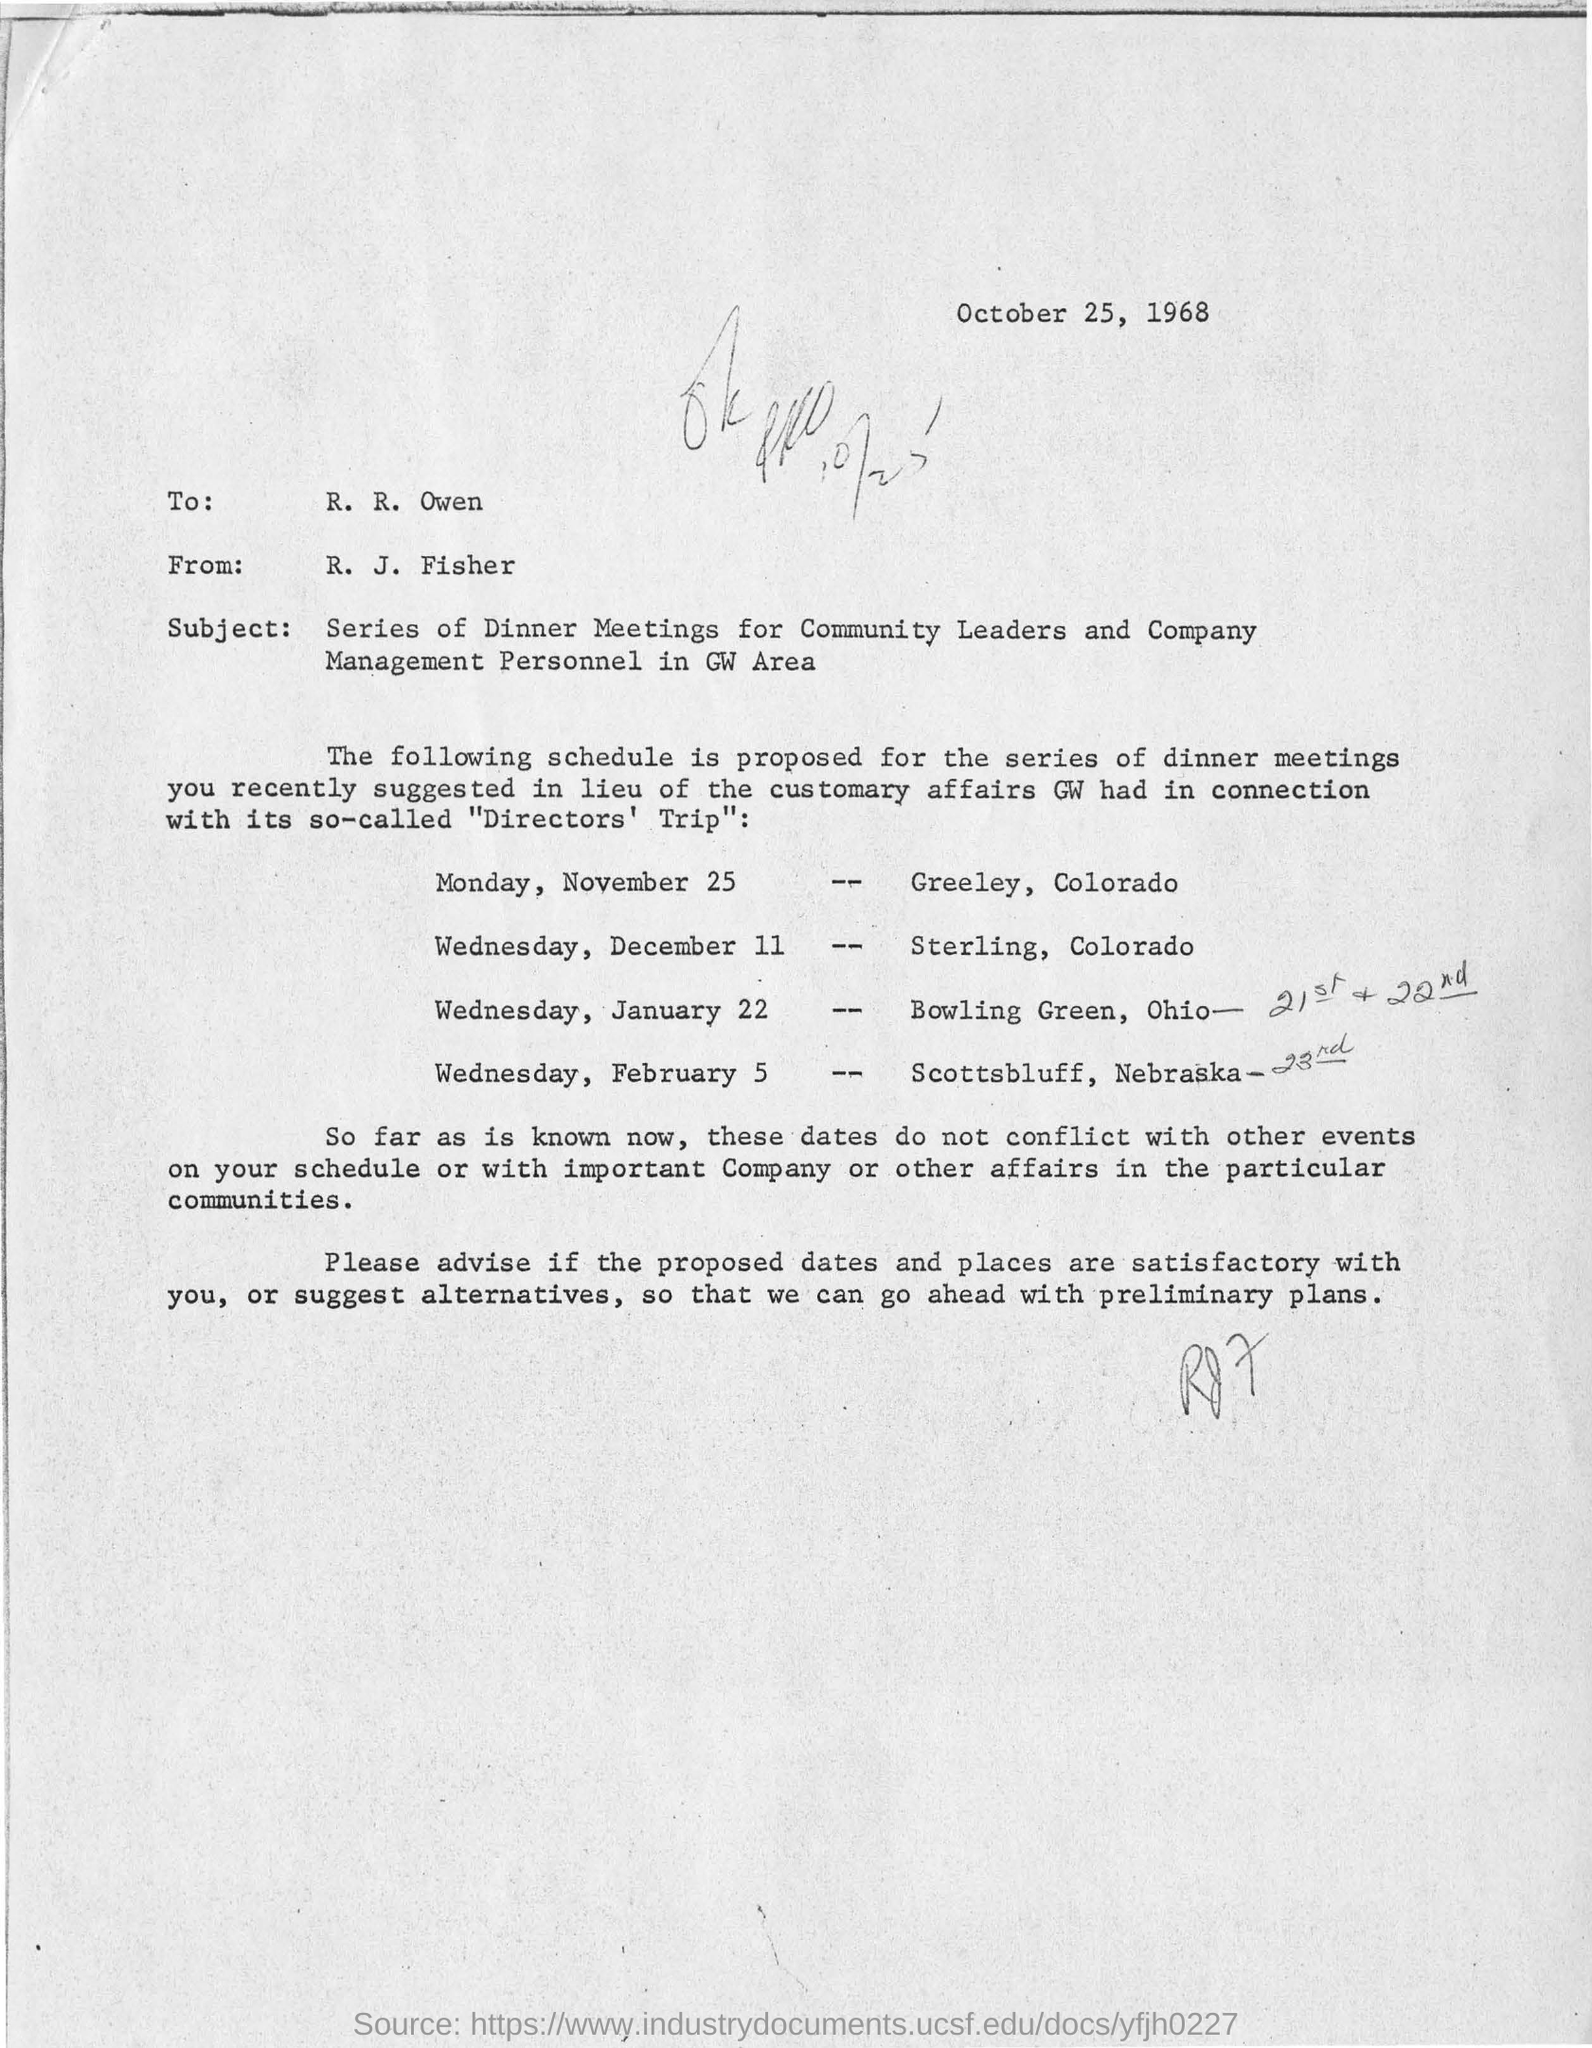Point out several critical features in this image. The Dineer meeting for Greeley, Colorado is scheduled for Monday, November 25. The letter is from someone named R. J. Fisher. The letter is addressed to R. R. Owen. The date on the letter is October 25, 1968. 